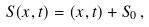Convert formula to latex. <formula><loc_0><loc_0><loc_500><loc_500>S ( x , t ) = ( x , t ) + S _ { 0 } \, ,</formula> 